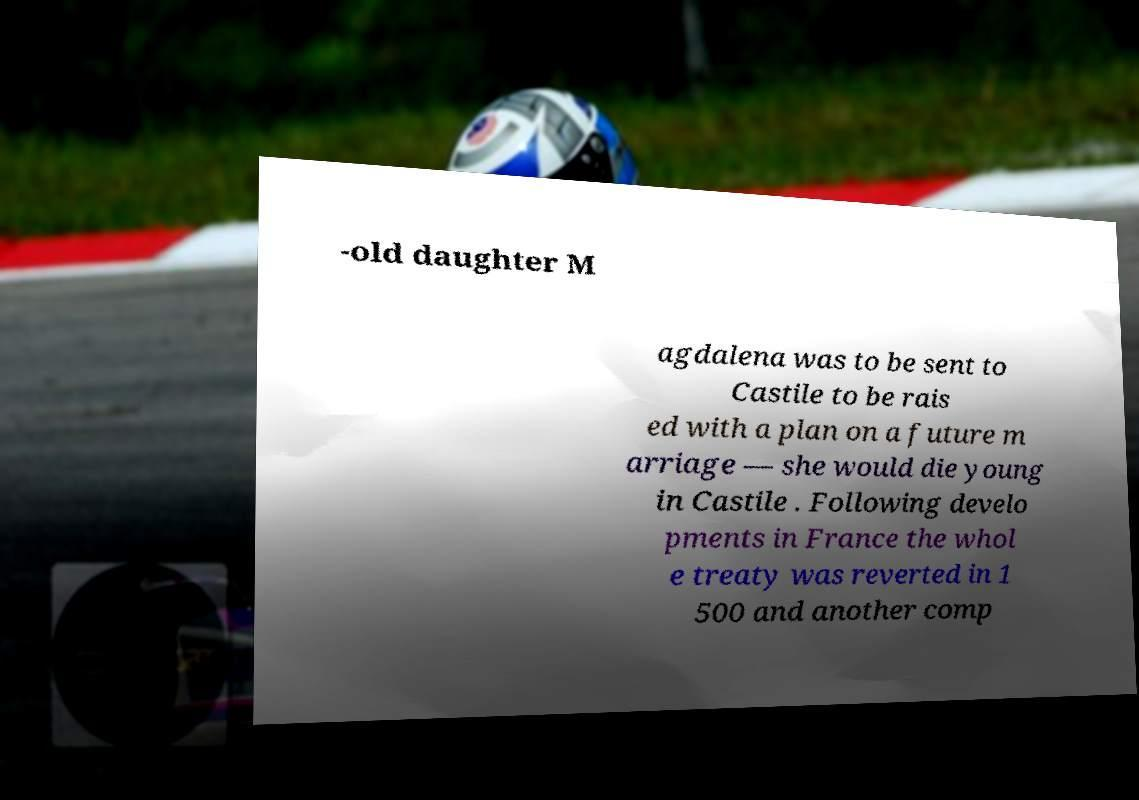For documentation purposes, I need the text within this image transcribed. Could you provide that? -old daughter M agdalena was to be sent to Castile to be rais ed with a plan on a future m arriage — she would die young in Castile . Following develo pments in France the whol e treaty was reverted in 1 500 and another comp 